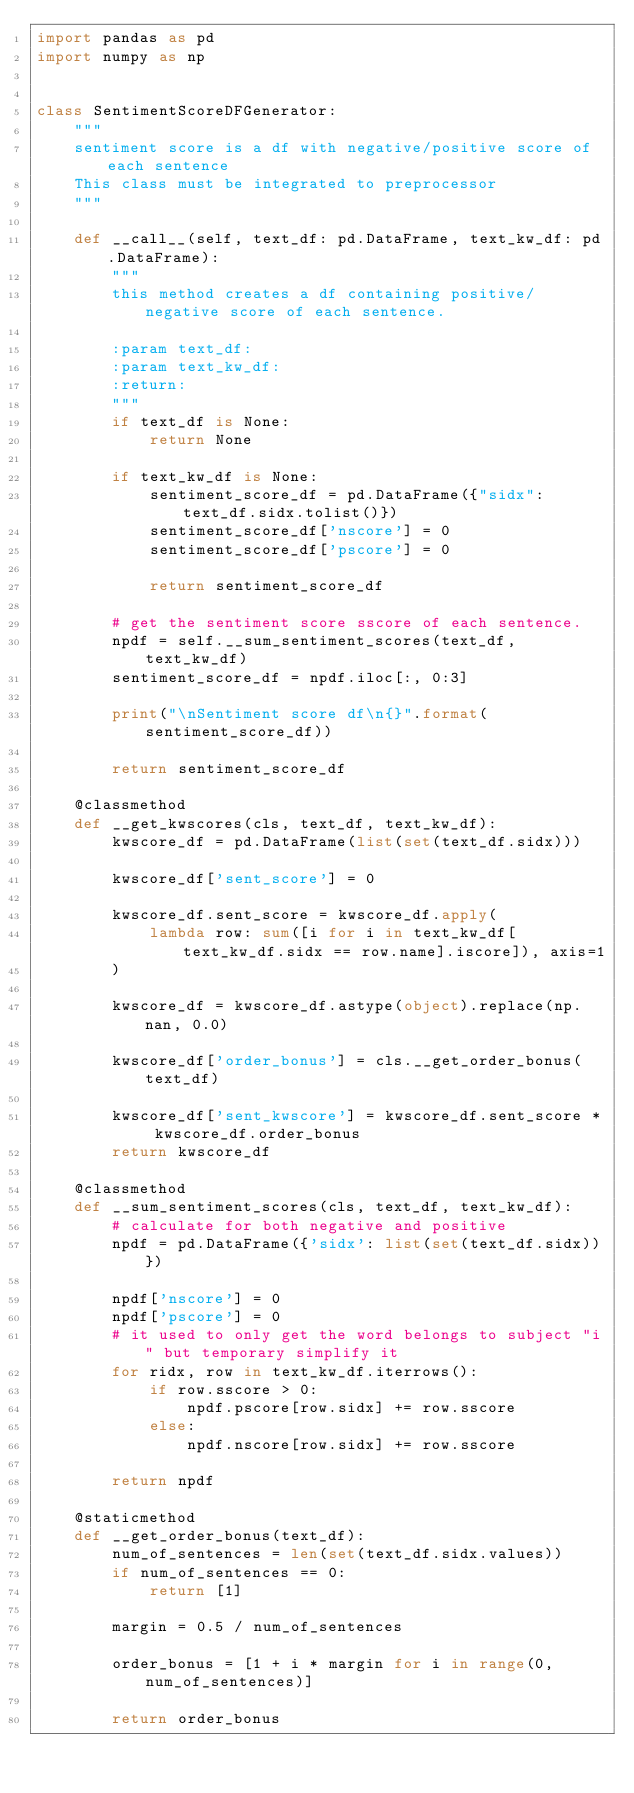<code> <loc_0><loc_0><loc_500><loc_500><_Python_>import pandas as pd
import numpy as np


class SentimentScoreDFGenerator:
    """
    sentiment score is a df with negative/positive score of each sentence
    This class must be integrated to preprocessor
    """

    def __call__(self, text_df: pd.DataFrame, text_kw_df: pd.DataFrame):
        """
        this method creates a df containing positive/negative score of each sentence.

        :param text_df:
        :param text_kw_df:
        :return:
        """
        if text_df is None:
            return None

        if text_kw_df is None:
            sentiment_score_df = pd.DataFrame({"sidx": text_df.sidx.tolist()})
            sentiment_score_df['nscore'] = 0
            sentiment_score_df['pscore'] = 0

            return sentiment_score_df

        # get the sentiment score sscore of each sentence.
        npdf = self.__sum_sentiment_scores(text_df, text_kw_df)
        sentiment_score_df = npdf.iloc[:, 0:3]

        print("\nSentiment score df\n{}".format(sentiment_score_df))

        return sentiment_score_df

    @classmethod
    def __get_kwscores(cls, text_df, text_kw_df):
        kwscore_df = pd.DataFrame(list(set(text_df.sidx)))

        kwscore_df['sent_score'] = 0

        kwscore_df.sent_score = kwscore_df.apply(
            lambda row: sum([i for i in text_kw_df[text_kw_df.sidx == row.name].iscore]), axis=1
        )

        kwscore_df = kwscore_df.astype(object).replace(np.nan, 0.0)

        kwscore_df['order_bonus'] = cls.__get_order_bonus(text_df)

        kwscore_df['sent_kwscore'] = kwscore_df.sent_score * kwscore_df.order_bonus
        return kwscore_df

    @classmethod
    def __sum_sentiment_scores(cls, text_df, text_kw_df):
        # calculate for both negative and positive
        npdf = pd.DataFrame({'sidx': list(set(text_df.sidx))})

        npdf['nscore'] = 0
        npdf['pscore'] = 0
        # it used to only get the word belongs to subject "i" but temporary simplify it
        for ridx, row in text_kw_df.iterrows():
            if row.sscore > 0:
                npdf.pscore[row.sidx] += row.sscore
            else:
                npdf.nscore[row.sidx] += row.sscore

        return npdf

    @staticmethod
    def __get_order_bonus(text_df):
        num_of_sentences = len(set(text_df.sidx.values))
        if num_of_sentences == 0:
            return [1]

        margin = 0.5 / num_of_sentences

        order_bonus = [1 + i * margin for i in range(0, num_of_sentences)]

        return order_bonus
</code> 